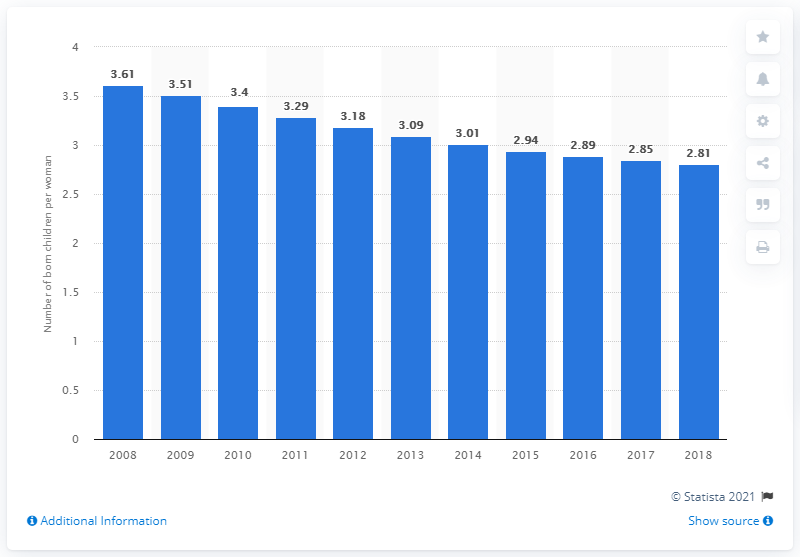Highlight a few significant elements in this photo. In 2018, the fertility rate in Syria was 2.81, indicating a stable population growth rate. 